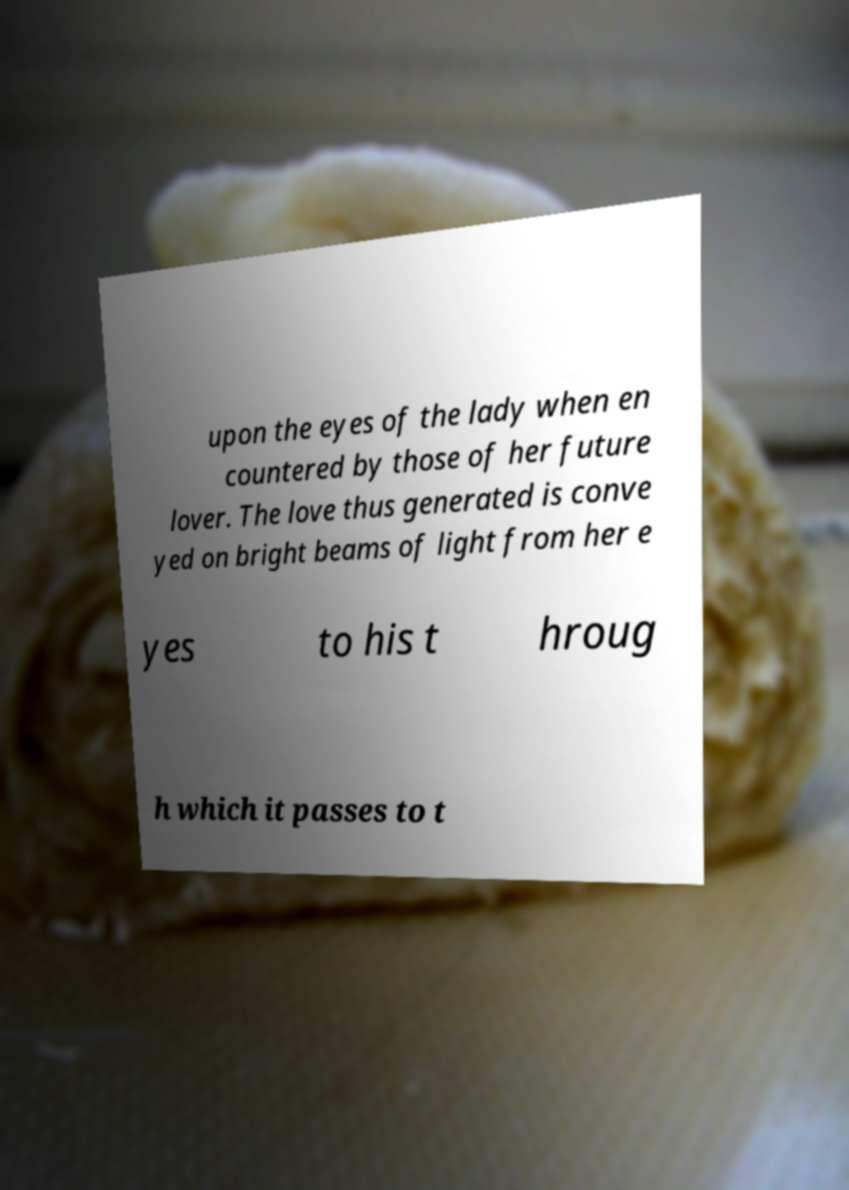Could you extract and type out the text from this image? upon the eyes of the lady when en countered by those of her future lover. The love thus generated is conve yed on bright beams of light from her e yes to his t hroug h which it passes to t 